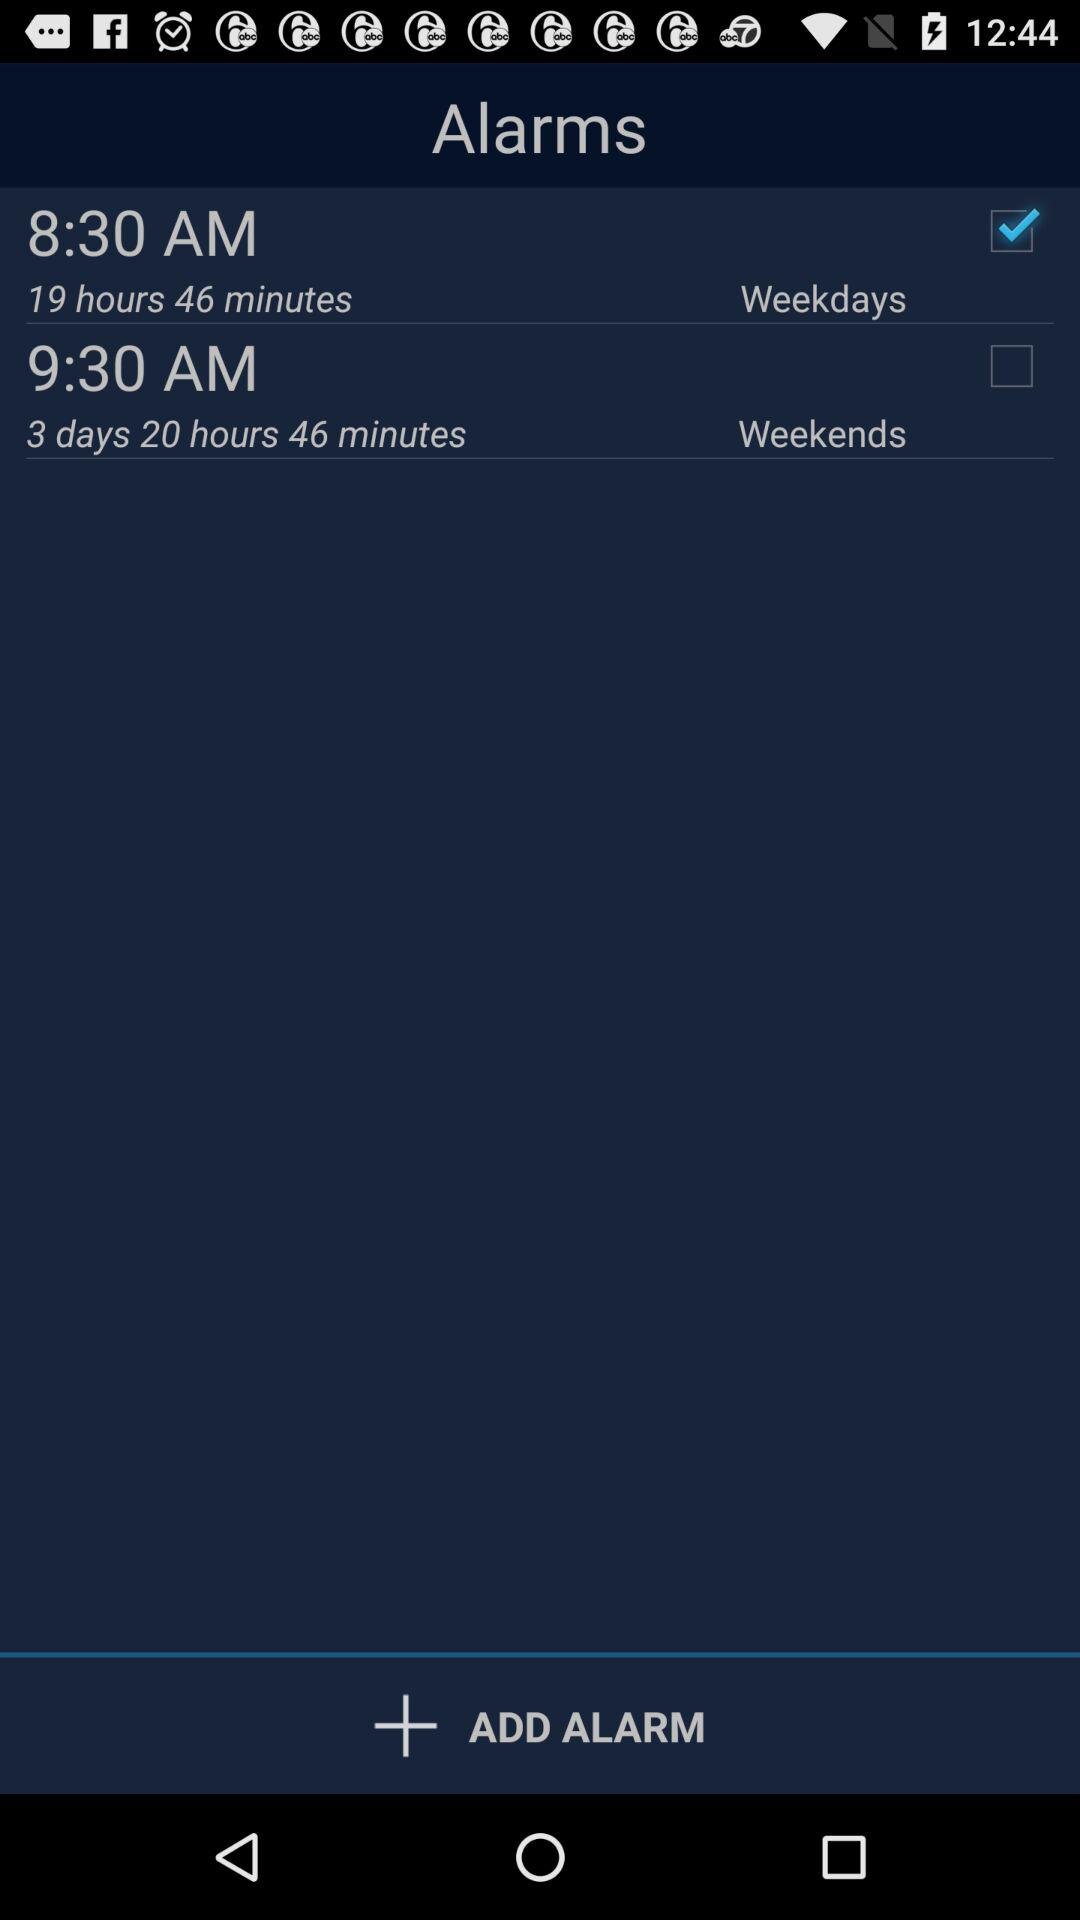For what time alarm has been selected? The selected alarms are set at 8:30 AM. 